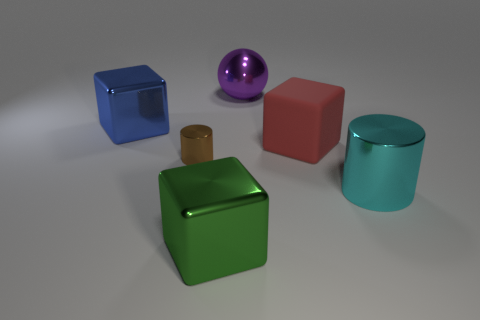Add 1 metal cylinders. How many objects exist? 7 Subtract all large metal blocks. How many blocks are left? 1 Subtract all red blocks. How many blocks are left? 2 Subtract all large cyan metal cylinders. Subtract all big matte cubes. How many objects are left? 4 Add 5 tiny brown cylinders. How many tiny brown cylinders are left? 6 Add 6 tiny brown things. How many tiny brown things exist? 7 Subtract 0 cyan cubes. How many objects are left? 6 Subtract all balls. How many objects are left? 5 Subtract 1 cylinders. How many cylinders are left? 1 Subtract all gray cylinders. Subtract all yellow cubes. How many cylinders are left? 2 